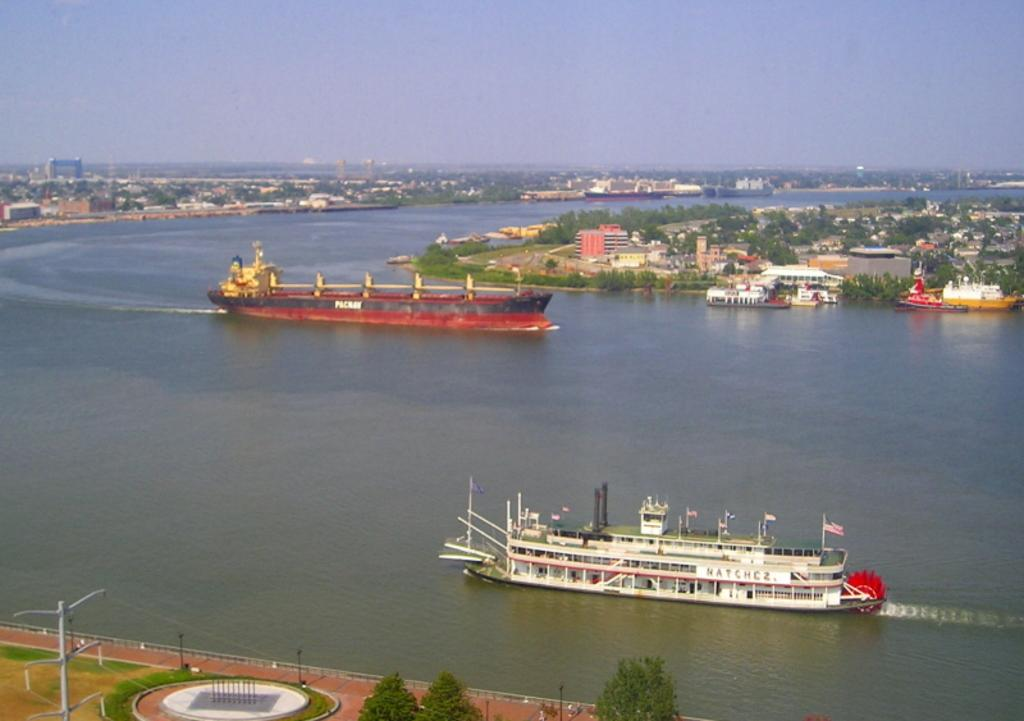What structures are present in the image? There are poles, buildings, and trees in the image. What type of natural environment is visible in the image? There is grass and trees in the image. What can be seen on the water in the image? There are ships on the water in the image. What is visible in the background of the image? The sky is visible in the background of the image. Can you hear the beetle crying in the image? There is no beetle or crying sound present in the image. What type of test is being conducted in the image? There is no test or testing activity depicted in the image. 